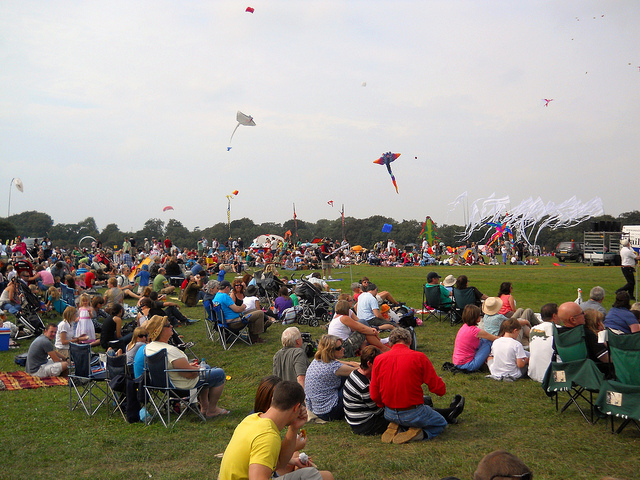What type toys unite these people today?
A. chairs
B. toys
C. drones
D. trucks
Answer with the option's letter from the given choices directly. B Why are there more people than kites?
A. lazy people
B. some hidden
C. mostly spectators
D. lost some C 